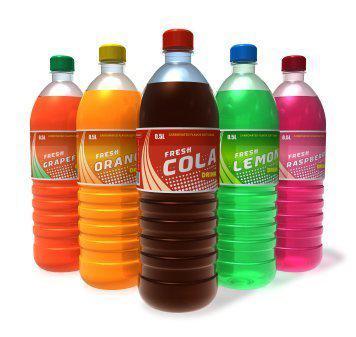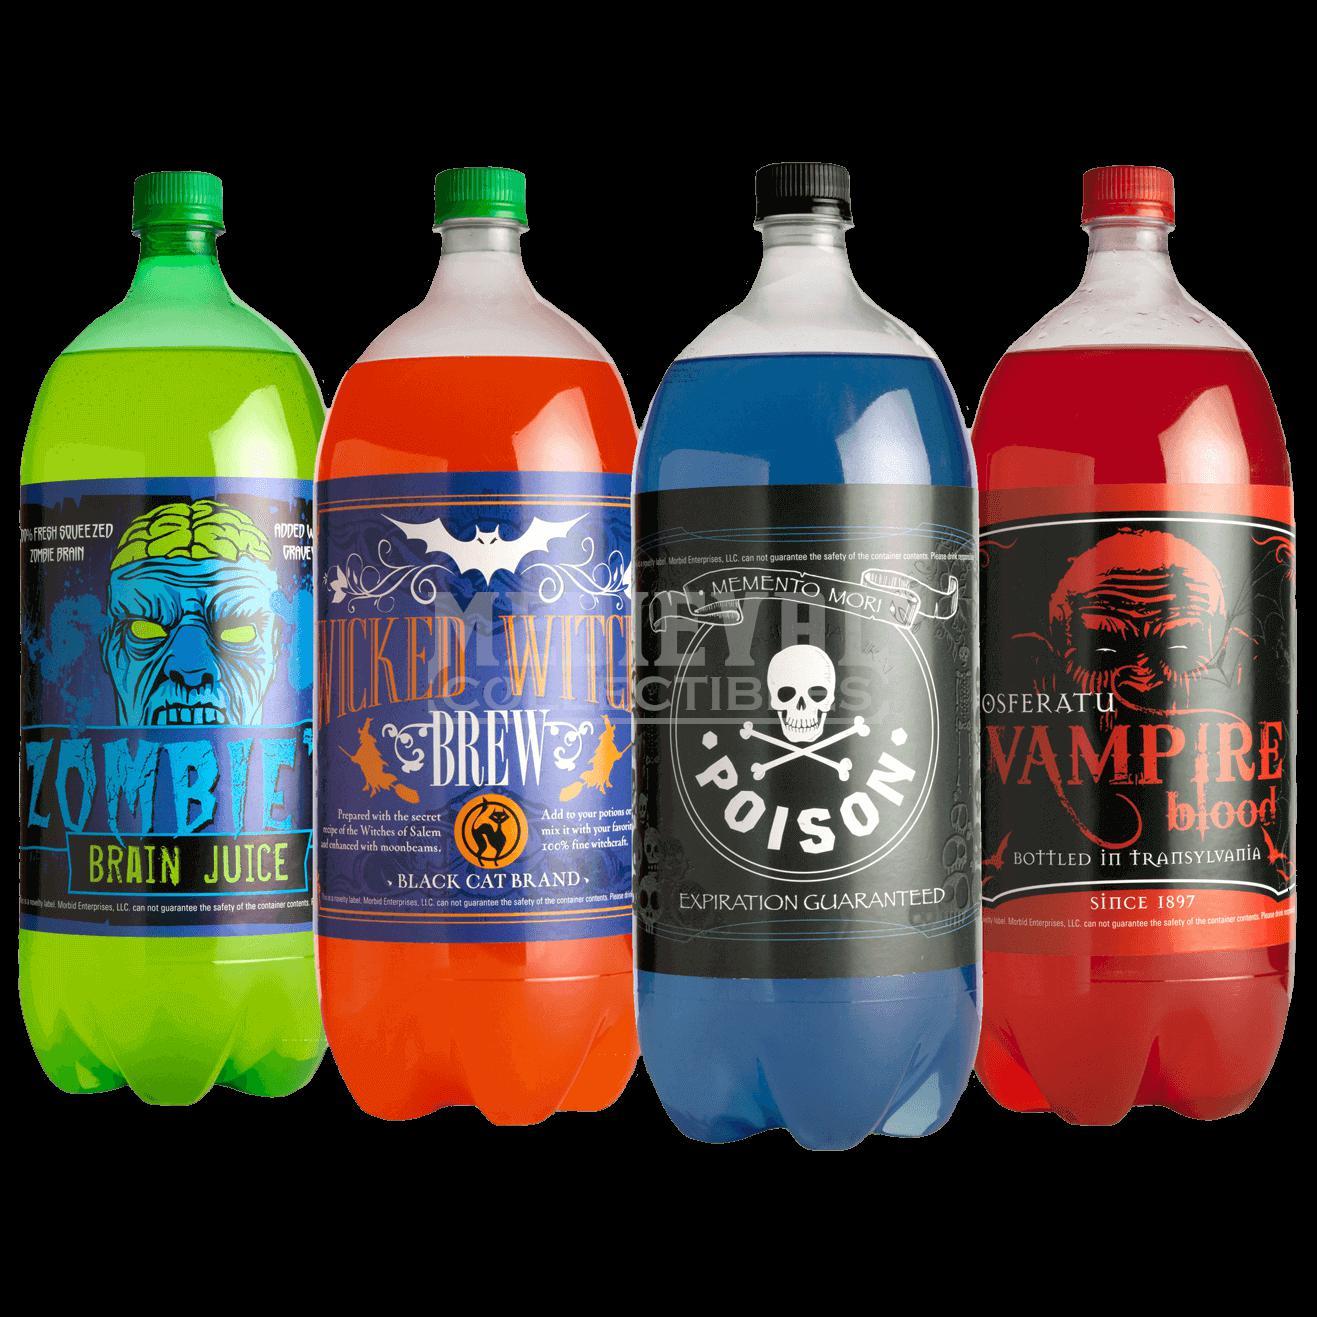The first image is the image on the left, the second image is the image on the right. For the images displayed, is the sentence "All bottles contain colored liquids and have labels and caps on." factually correct? Answer yes or no. Yes. The first image is the image on the left, the second image is the image on the right. Considering the images on both sides, is "There are no more than 3 bottles in the image on the left." valid? Answer yes or no. No. 